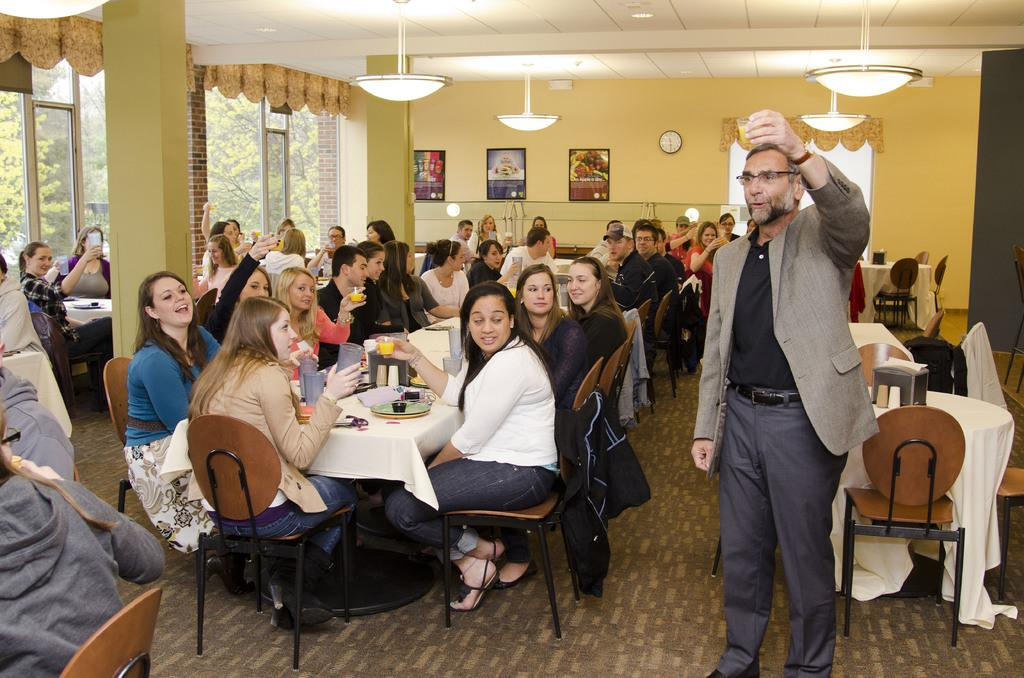What is the person in the image wearing? The person is wearing a coat in the image. What is the person doing in the image? The person is standing in the image. What is the person holding in their hand? The person is holding a drink in their left hand. Are there any other people in the image? Yes, there is a group of people beside the person. What color is the background wall in the image? The background wall is light yellow in color. What type of basket is the person carrying in the image? There is no basket present in the image. How does the person get the attention of the group of people in the image? The image does not show any actions or expressions that indicate the person is trying to get the attention of the group of people. 